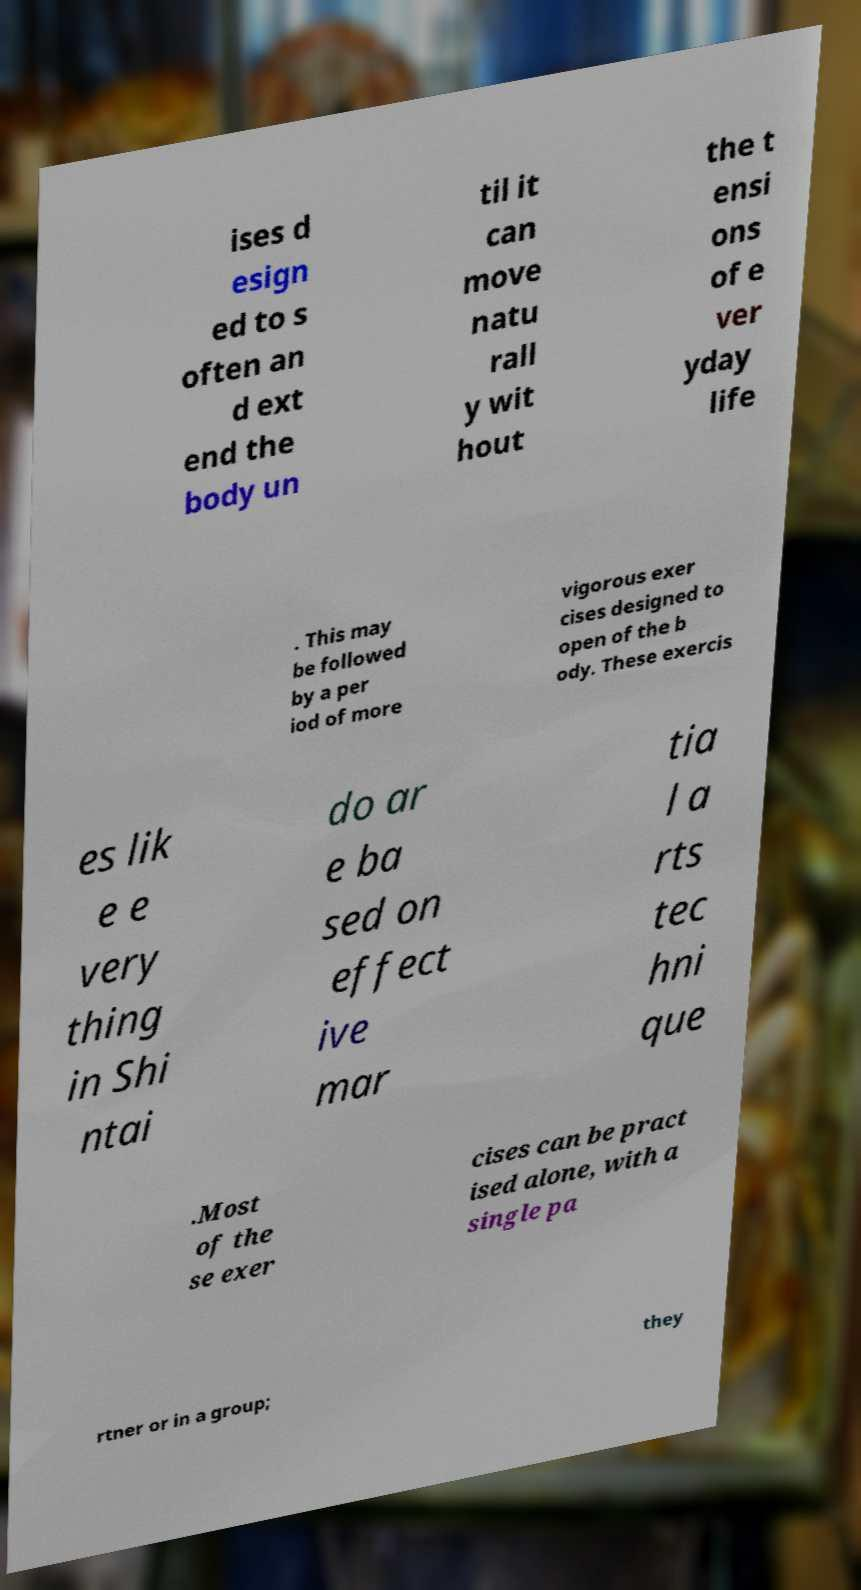What messages or text are displayed in this image? I need them in a readable, typed format. ises d esign ed to s often an d ext end the body un til it can move natu rall y wit hout the t ensi ons of e ver yday life . This may be followed by a per iod of more vigorous exer cises designed to open of the b ody. These exercis es lik e e very thing in Shi ntai do ar e ba sed on effect ive mar tia l a rts tec hni que .Most of the se exer cises can be pract ised alone, with a single pa rtner or in a group; they 